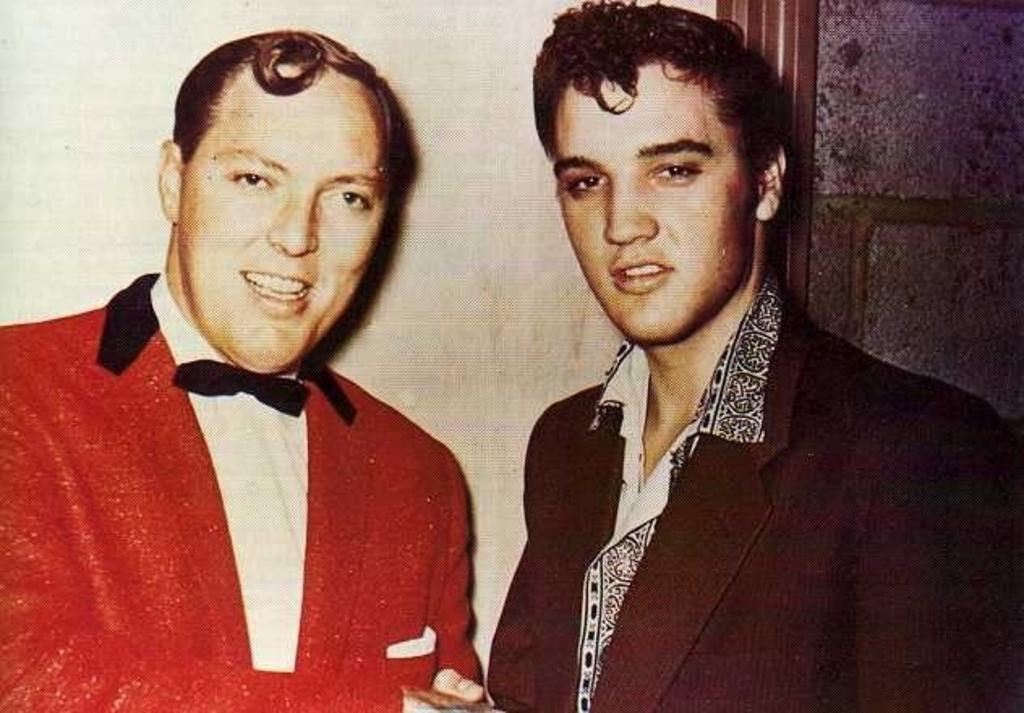In one or two sentences, can you explain what this image depicts? Here I can see two men wearing suits, smiling and giving pose for the picture. At the back of these people there is a wall. On the right side there is an object which seems to be a door. 